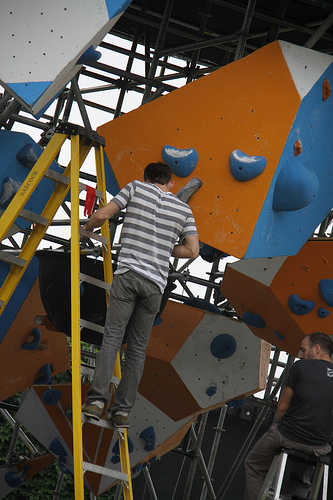<image>
Can you confirm if the man is above the ladder? No. The man is not positioned above the ladder. The vertical arrangement shows a different relationship. 